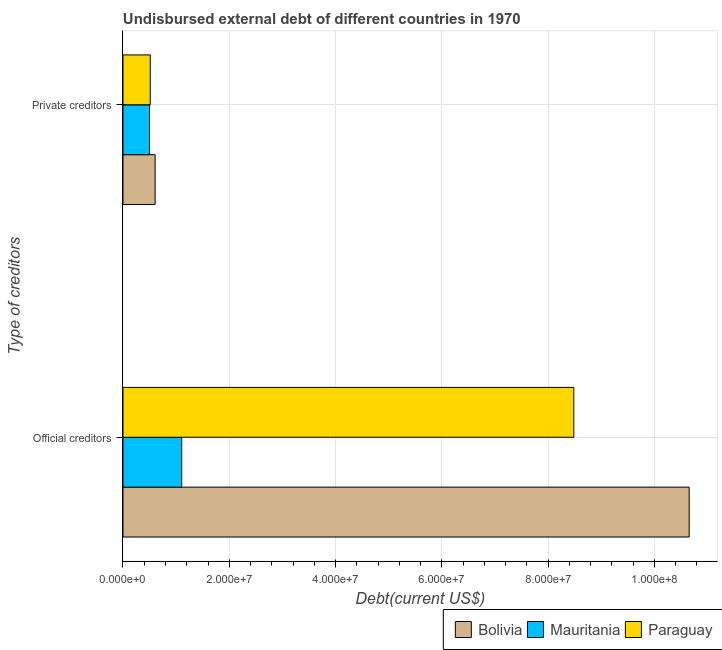How many different coloured bars are there?
Provide a short and direct response. 3. How many groups of bars are there?
Your answer should be very brief. 2. Are the number of bars on each tick of the Y-axis equal?
Provide a short and direct response. Yes. How many bars are there on the 1st tick from the top?
Make the answer very short. 3. What is the label of the 2nd group of bars from the top?
Provide a short and direct response. Official creditors. What is the undisbursed external debt of official creditors in Mauritania?
Your response must be concise. 1.10e+07. Across all countries, what is the maximum undisbursed external debt of official creditors?
Provide a succinct answer. 1.07e+08. Across all countries, what is the minimum undisbursed external debt of official creditors?
Offer a terse response. 1.10e+07. In which country was the undisbursed external debt of official creditors minimum?
Your answer should be compact. Mauritania. What is the total undisbursed external debt of official creditors in the graph?
Your answer should be very brief. 2.02e+08. What is the difference between the undisbursed external debt of private creditors in Mauritania and that in Paraguay?
Ensure brevity in your answer.  -1.33e+05. What is the difference between the undisbursed external debt of private creditors in Mauritania and the undisbursed external debt of official creditors in Bolivia?
Provide a succinct answer. -1.02e+08. What is the average undisbursed external debt of official creditors per country?
Your response must be concise. 6.75e+07. What is the difference between the undisbursed external debt of official creditors and undisbursed external debt of private creditors in Paraguay?
Ensure brevity in your answer.  7.97e+07. What is the ratio of the undisbursed external debt of official creditors in Bolivia to that in Mauritania?
Offer a very short reply. 9.65. Is the undisbursed external debt of official creditors in Bolivia less than that in Paraguay?
Your answer should be very brief. No. What does the 3rd bar from the top in Private creditors represents?
Offer a terse response. Bolivia. What does the 2nd bar from the bottom in Private creditors represents?
Provide a succinct answer. Mauritania. Are all the bars in the graph horizontal?
Make the answer very short. Yes. How many countries are there in the graph?
Your answer should be compact. 3. What is the difference between two consecutive major ticks on the X-axis?
Give a very brief answer. 2.00e+07. Does the graph contain any zero values?
Offer a terse response. No. How many legend labels are there?
Your response must be concise. 3. What is the title of the graph?
Your response must be concise. Undisbursed external debt of different countries in 1970. Does "Czech Republic" appear as one of the legend labels in the graph?
Your answer should be compact. No. What is the label or title of the X-axis?
Offer a very short reply. Debt(current US$). What is the label or title of the Y-axis?
Offer a terse response. Type of creditors. What is the Debt(current US$) of Bolivia in Official creditors?
Provide a short and direct response. 1.07e+08. What is the Debt(current US$) of Mauritania in Official creditors?
Provide a succinct answer. 1.10e+07. What is the Debt(current US$) in Paraguay in Official creditors?
Provide a short and direct response. 8.48e+07. What is the Debt(current US$) in Bolivia in Private creditors?
Your answer should be compact. 6.05e+06. What is the Debt(current US$) of Paraguay in Private creditors?
Make the answer very short. 5.13e+06. Across all Type of creditors, what is the maximum Debt(current US$) of Bolivia?
Ensure brevity in your answer.  1.07e+08. Across all Type of creditors, what is the maximum Debt(current US$) in Mauritania?
Give a very brief answer. 1.10e+07. Across all Type of creditors, what is the maximum Debt(current US$) in Paraguay?
Give a very brief answer. 8.48e+07. Across all Type of creditors, what is the minimum Debt(current US$) of Bolivia?
Provide a short and direct response. 6.05e+06. Across all Type of creditors, what is the minimum Debt(current US$) of Mauritania?
Offer a very short reply. 5.00e+06. Across all Type of creditors, what is the minimum Debt(current US$) in Paraguay?
Provide a succinct answer. 5.13e+06. What is the total Debt(current US$) in Bolivia in the graph?
Ensure brevity in your answer.  1.13e+08. What is the total Debt(current US$) of Mauritania in the graph?
Provide a succinct answer. 1.60e+07. What is the total Debt(current US$) of Paraguay in the graph?
Provide a short and direct response. 9.00e+07. What is the difference between the Debt(current US$) of Bolivia in Official creditors and that in Private creditors?
Keep it short and to the point. 1.00e+08. What is the difference between the Debt(current US$) in Mauritania in Official creditors and that in Private creditors?
Offer a very short reply. 6.04e+06. What is the difference between the Debt(current US$) in Paraguay in Official creditors and that in Private creditors?
Your answer should be very brief. 7.97e+07. What is the difference between the Debt(current US$) of Bolivia in Official creditors and the Debt(current US$) of Mauritania in Private creditors?
Ensure brevity in your answer.  1.02e+08. What is the difference between the Debt(current US$) of Bolivia in Official creditors and the Debt(current US$) of Paraguay in Private creditors?
Provide a succinct answer. 1.01e+08. What is the difference between the Debt(current US$) of Mauritania in Official creditors and the Debt(current US$) of Paraguay in Private creditors?
Give a very brief answer. 5.91e+06. What is the average Debt(current US$) of Bolivia per Type of creditors?
Ensure brevity in your answer.  5.63e+07. What is the average Debt(current US$) in Mauritania per Type of creditors?
Offer a terse response. 8.02e+06. What is the average Debt(current US$) of Paraguay per Type of creditors?
Offer a very short reply. 4.50e+07. What is the difference between the Debt(current US$) of Bolivia and Debt(current US$) of Mauritania in Official creditors?
Your response must be concise. 9.55e+07. What is the difference between the Debt(current US$) of Bolivia and Debt(current US$) of Paraguay in Official creditors?
Give a very brief answer. 2.17e+07. What is the difference between the Debt(current US$) of Mauritania and Debt(current US$) of Paraguay in Official creditors?
Your answer should be compact. -7.38e+07. What is the difference between the Debt(current US$) of Bolivia and Debt(current US$) of Mauritania in Private creditors?
Provide a short and direct response. 1.05e+06. What is the difference between the Debt(current US$) of Bolivia and Debt(current US$) of Paraguay in Private creditors?
Ensure brevity in your answer.  9.15e+05. What is the difference between the Debt(current US$) of Mauritania and Debt(current US$) of Paraguay in Private creditors?
Your answer should be very brief. -1.33e+05. What is the ratio of the Debt(current US$) of Bolivia in Official creditors to that in Private creditors?
Offer a very short reply. 17.61. What is the ratio of the Debt(current US$) of Mauritania in Official creditors to that in Private creditors?
Your answer should be very brief. 2.21. What is the ratio of the Debt(current US$) in Paraguay in Official creditors to that in Private creditors?
Provide a succinct answer. 16.53. What is the difference between the highest and the second highest Debt(current US$) of Bolivia?
Give a very brief answer. 1.00e+08. What is the difference between the highest and the second highest Debt(current US$) in Mauritania?
Give a very brief answer. 6.04e+06. What is the difference between the highest and the second highest Debt(current US$) in Paraguay?
Your answer should be very brief. 7.97e+07. What is the difference between the highest and the lowest Debt(current US$) of Bolivia?
Make the answer very short. 1.00e+08. What is the difference between the highest and the lowest Debt(current US$) of Mauritania?
Give a very brief answer. 6.04e+06. What is the difference between the highest and the lowest Debt(current US$) in Paraguay?
Offer a terse response. 7.97e+07. 